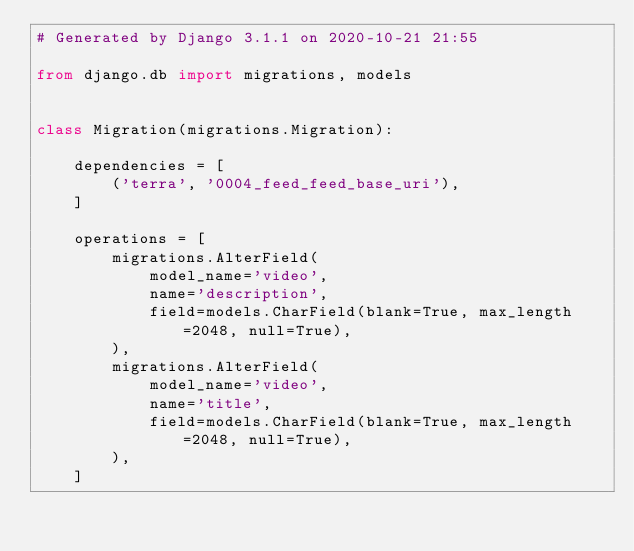Convert code to text. <code><loc_0><loc_0><loc_500><loc_500><_Python_># Generated by Django 3.1.1 on 2020-10-21 21:55

from django.db import migrations, models


class Migration(migrations.Migration):

    dependencies = [
        ('terra', '0004_feed_feed_base_uri'),
    ]

    operations = [
        migrations.AlterField(
            model_name='video',
            name='description',
            field=models.CharField(blank=True, max_length=2048, null=True),
        ),
        migrations.AlterField(
            model_name='video',
            name='title',
            field=models.CharField(blank=True, max_length=2048, null=True),
        ),
    ]
</code> 